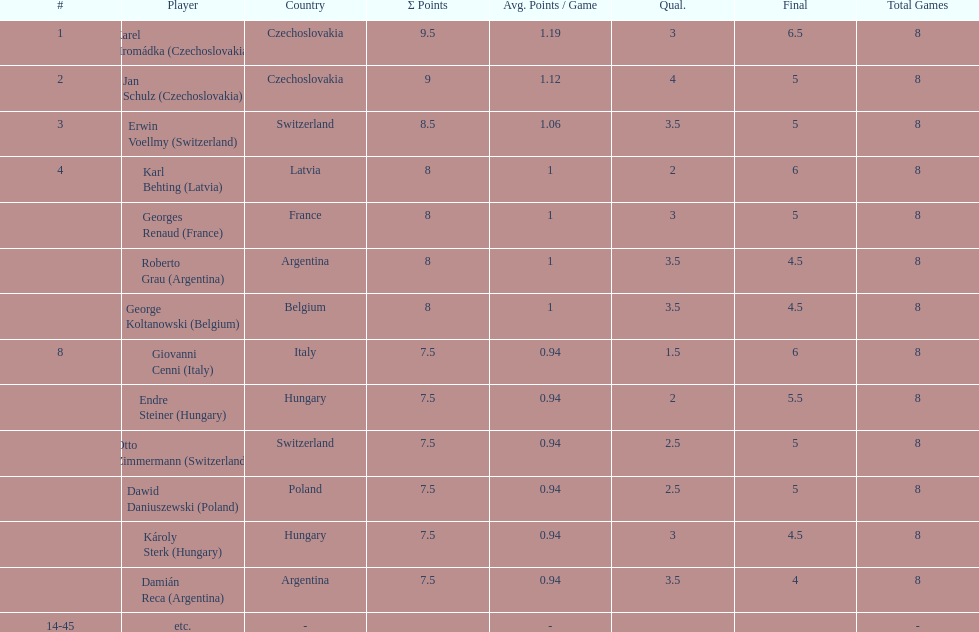Which player had the largest number of &#931; points? Karel Hromádka. 